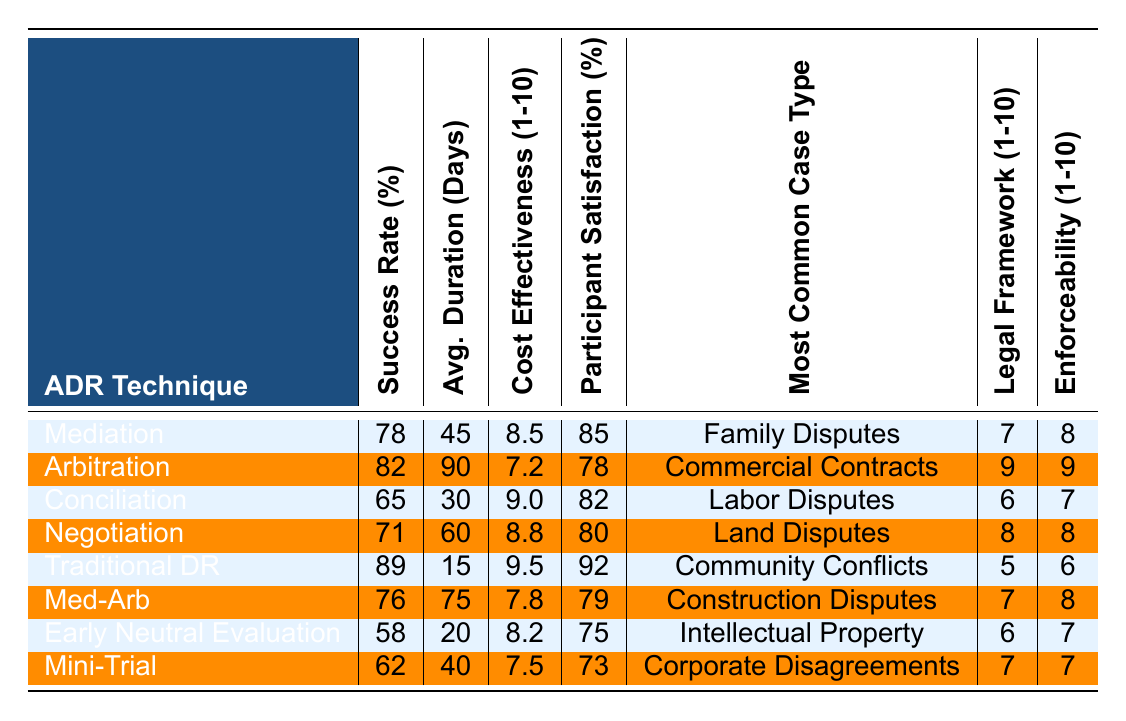What is the success rate of Traditional Dispute Resolution? The table lists the success rate for Traditional Dispute Resolution as 89%.
Answer: 89% Which ADR technique has the highest participant satisfaction? The participant satisfaction scores indicate Traditional Dispute Resolution has the highest score at 92%.
Answer: Traditional Dispute Resolution What is the average duration for Arbitration cases? According to the table, the average duration for Arbitration cases is 90 days.
Answer: 90 days What is the cost-effectiveness score for Conciliation? The cost-effectiveness score provided for Conciliation is 9.0.
Answer: 9.0 Which ADR technique has the lowest success rate, and what is that rate? The table shows that Early Neutral Evaluation has the lowest success rate of 58%.
Answer: 58% What is the average success rate of all ADR techniques listed? The average success rate can be calculated by adding all success rates (78 + 82 + 65 + 71 + 89 + 76 + 58 + 62 =  481) and dividing by the number of techniques (8). Thus, the average success rate is 481 / 8 = 60.125%.
Answer: 60.125% Does the Mediator score higher than Arbitration in terms of cost-effectiveness? The cost-effectiveness score for Mediation is 8.5, while Arbitration is 7.2. Therefore, yes, Mediation scores higher than Arbitration.
Answer: Yes If you consider the techniques with a success rate above 75%, how many of them also have an average duration of less than 60 days? Mediation (45 days), Traditional Dispute Resolution (15 days), and Negotiation (60 days) have success rates above 75%. Only Mediation and Traditional Dispute Resolution have durations less than 60 days, making a total of 2 techniques.
Answer: 2 techniques What is the relationship between success rate and enforceability score for the ADR techniques listed? By reviewing the table, a pattern shows that as the success rate increases, the enforceability score also tends to increase. For example, Traditional Dispute Resolution has the highest success rate and an enforceability score of 6, while Early Neutral Evaluation has the lowest score of 7. This indicates a positive relationship.
Answer: Positive relationship Which ADR technique is most commonly used for Community Conflicts? According to the table, Traditional Dispute Resolution is the most common technique used for Community Conflicts.
Answer: Traditional Dispute Resolution 